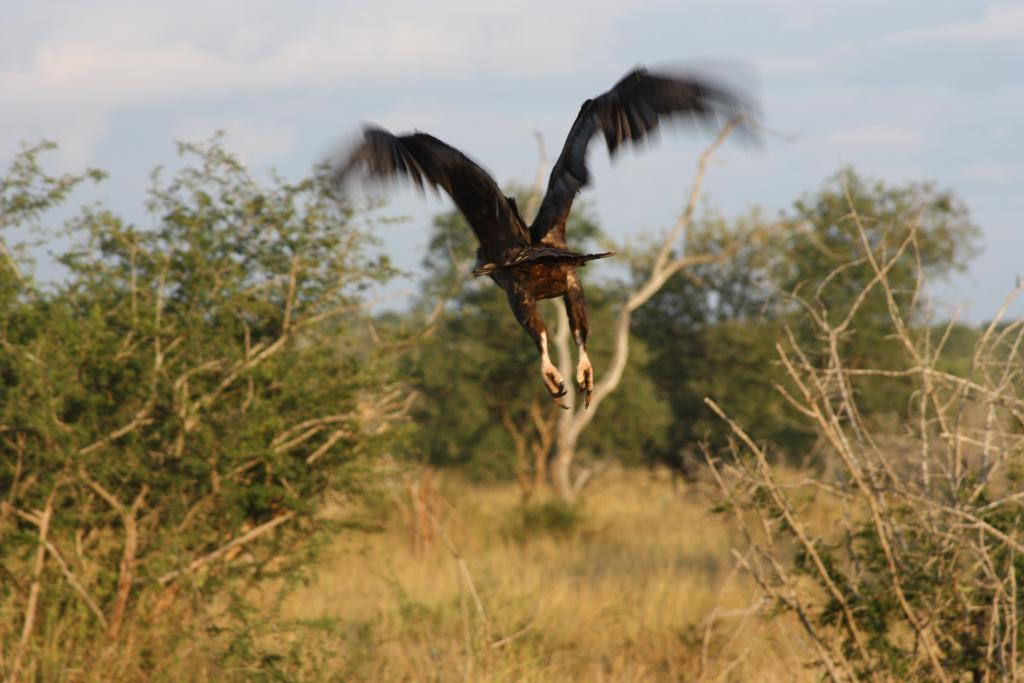What is the main subject of the image? There is a bird flying in the air in the image. What type of natural environment is depicted in the image? Trees are visible in the image. What can be seen in the background of the image? The sky is visible in the background of the image. What type of soap is being used by the bird in the image? There is no soap present in the image, as it features a bird flying in the air with trees and the sky visible in the background. 